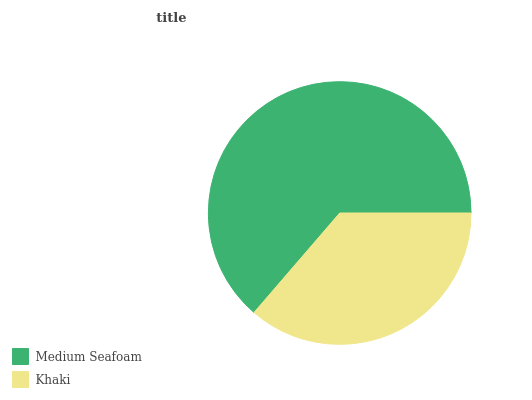Is Khaki the minimum?
Answer yes or no. Yes. Is Medium Seafoam the maximum?
Answer yes or no. Yes. Is Khaki the maximum?
Answer yes or no. No. Is Medium Seafoam greater than Khaki?
Answer yes or no. Yes. Is Khaki less than Medium Seafoam?
Answer yes or no. Yes. Is Khaki greater than Medium Seafoam?
Answer yes or no. No. Is Medium Seafoam less than Khaki?
Answer yes or no. No. Is Medium Seafoam the high median?
Answer yes or no. Yes. Is Khaki the low median?
Answer yes or no. Yes. Is Khaki the high median?
Answer yes or no. No. Is Medium Seafoam the low median?
Answer yes or no. No. 